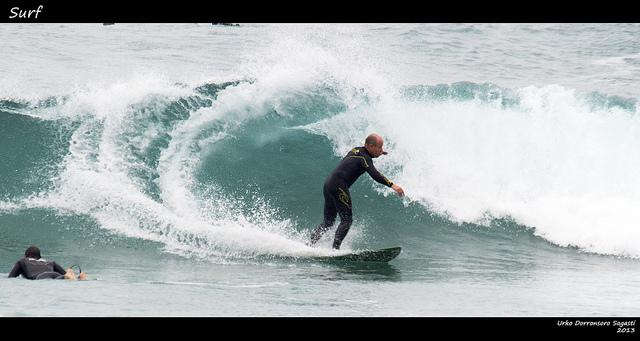What type of hairline does the standing man have?

Choices:
A) triangle
B) receding
C) straight
D) widow's peak receding 